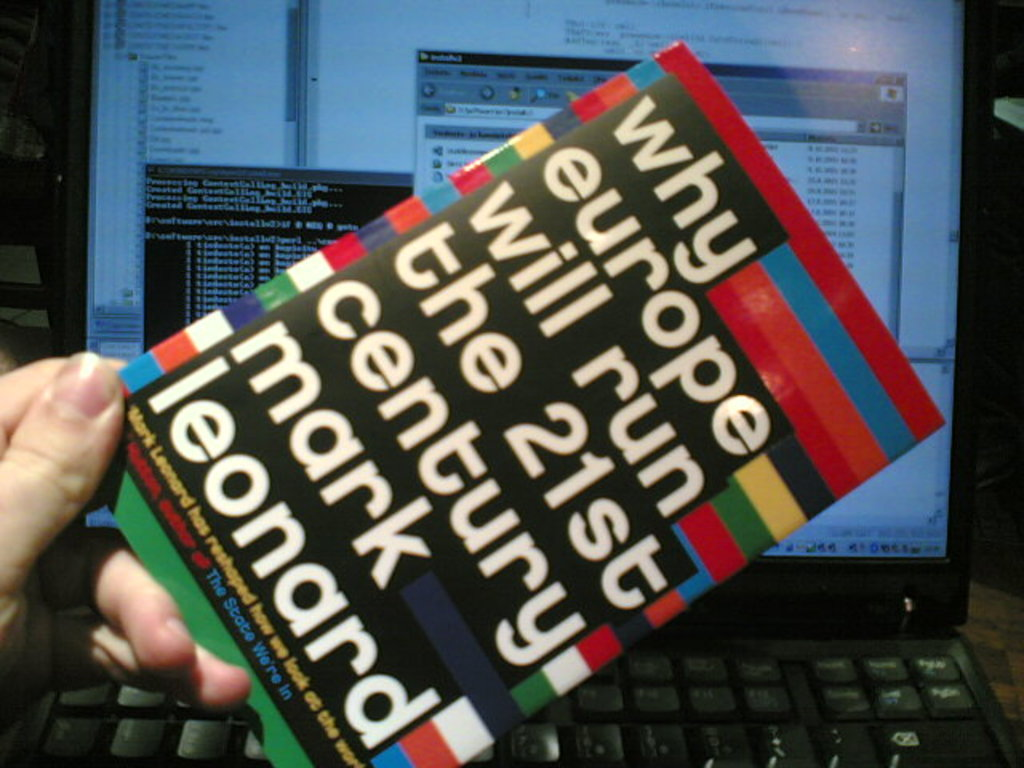Can you describe the context in which this photo was taken? The photo appears to have been taken in an office or personal workspace, as indicated by the arrangement of a keyboard and a computer monitor in the background, suggesting a moment of research or study. How could this image be symbolic of today's information culture? This image captures the intersection of traditional and digital mediums of information—holding a physical book on political analysis in front of a digital display reflects how modern learning and dissemination of ideas often merge print and digital sources. 